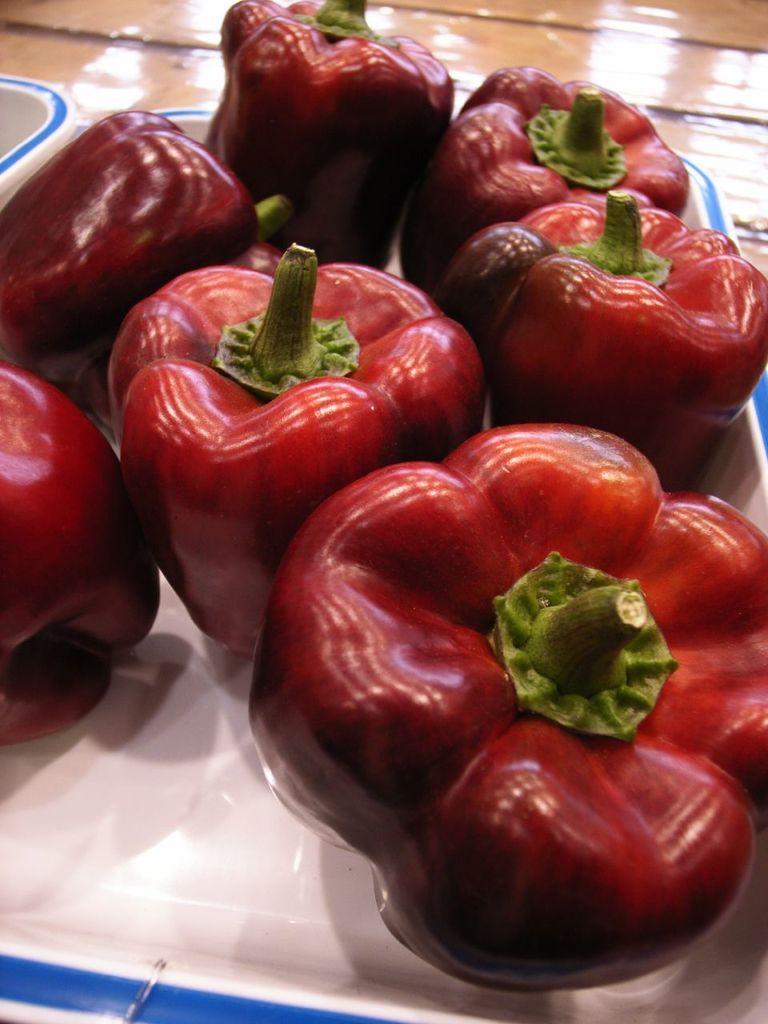Please provide a concise description of this image. In this image, we can see a plate contains some big chilies. 